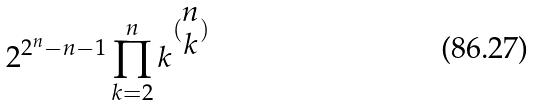Convert formula to latex. <formula><loc_0><loc_0><loc_500><loc_500>2 ^ { 2 ^ { n } - n - 1 } \prod _ { k = 2 } ^ { n } k ^ { ( \begin{matrix} n \\ k \end{matrix} ) }</formula> 